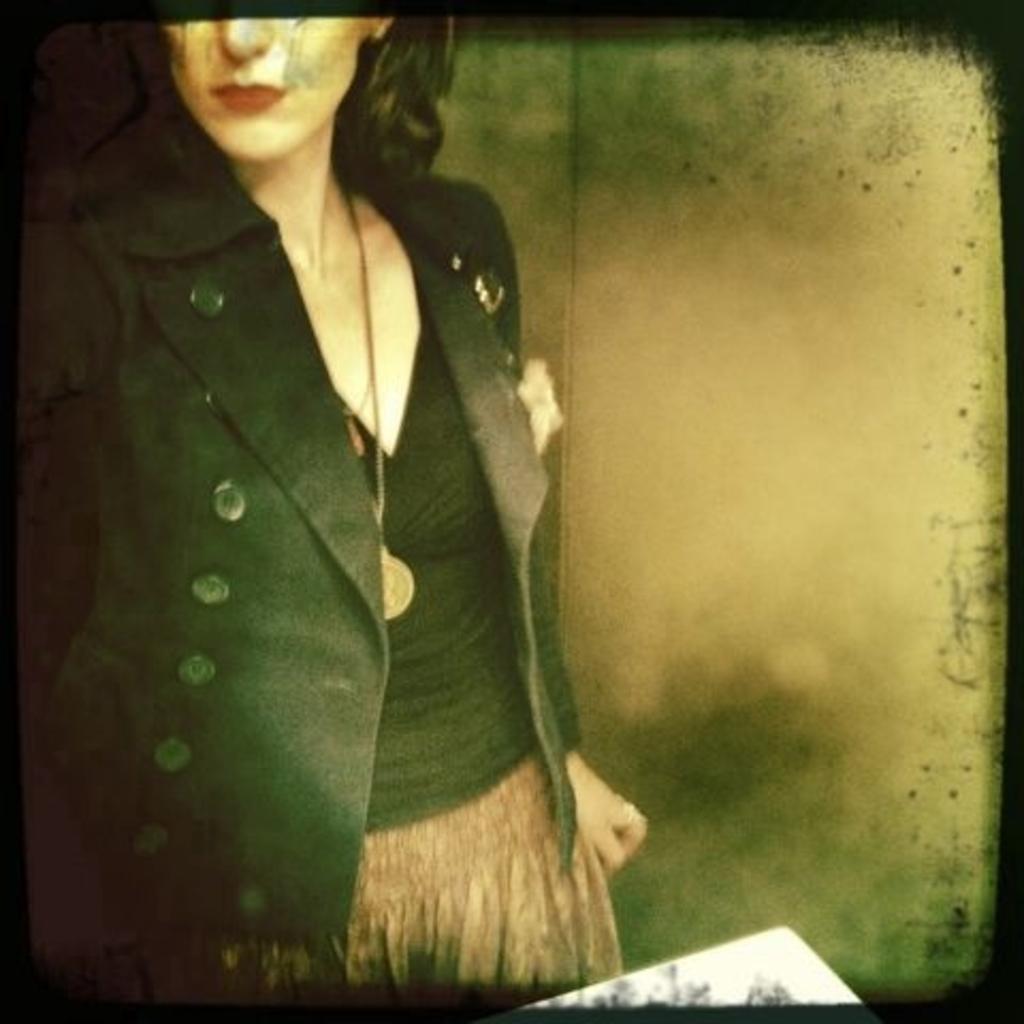In one or two sentences, can you explain what this image depicts? In the image we can see a screen, in it we can see a woman wearing clothes and neck chain. 